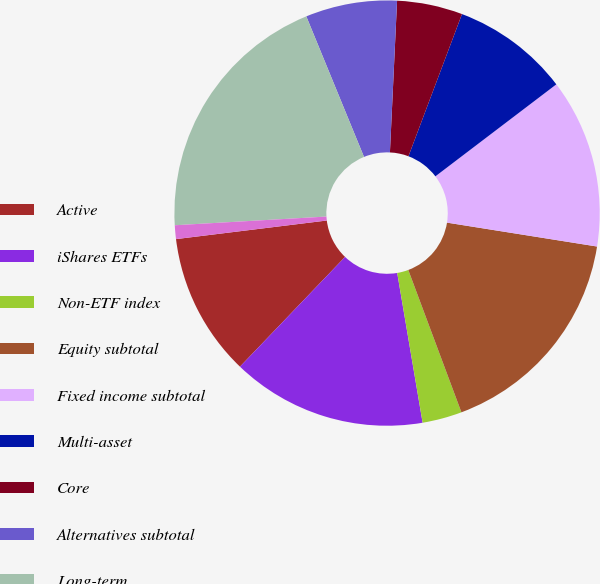Convert chart. <chart><loc_0><loc_0><loc_500><loc_500><pie_chart><fcel>Active<fcel>iShares ETFs<fcel>Non-ETF index<fcel>Equity subtotal<fcel>Fixed income subtotal<fcel>Multi-asset<fcel>Core<fcel>Alternatives subtotal<fcel>Long-term<fcel>Cash management<nl><fcel>10.89%<fcel>14.83%<fcel>3.01%<fcel>16.8%<fcel>12.86%<fcel>8.92%<fcel>4.98%<fcel>6.95%<fcel>19.71%<fcel>1.04%<nl></chart> 